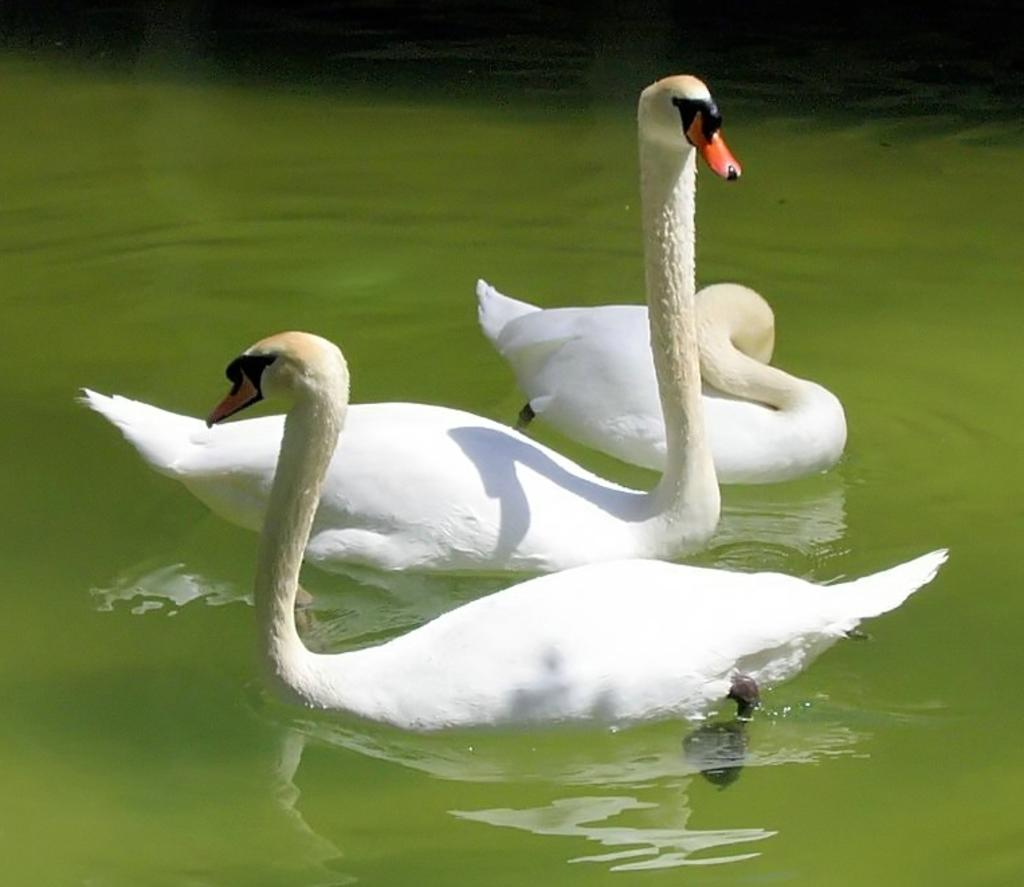What is the main subject of the image? The main subject of the image is a clear lake. What can be seen in the middle of the lake? There are three swans in the middle of the lake. What is the color of the swans? The swans are white in color. What type of authority figure can be seen in the image? There is no authority figure present in the image; it features a clear lake with three white swans. What type of secretary can be seen working in the image? There is no secretary present in the image; it features a clear lake with three white swans. 